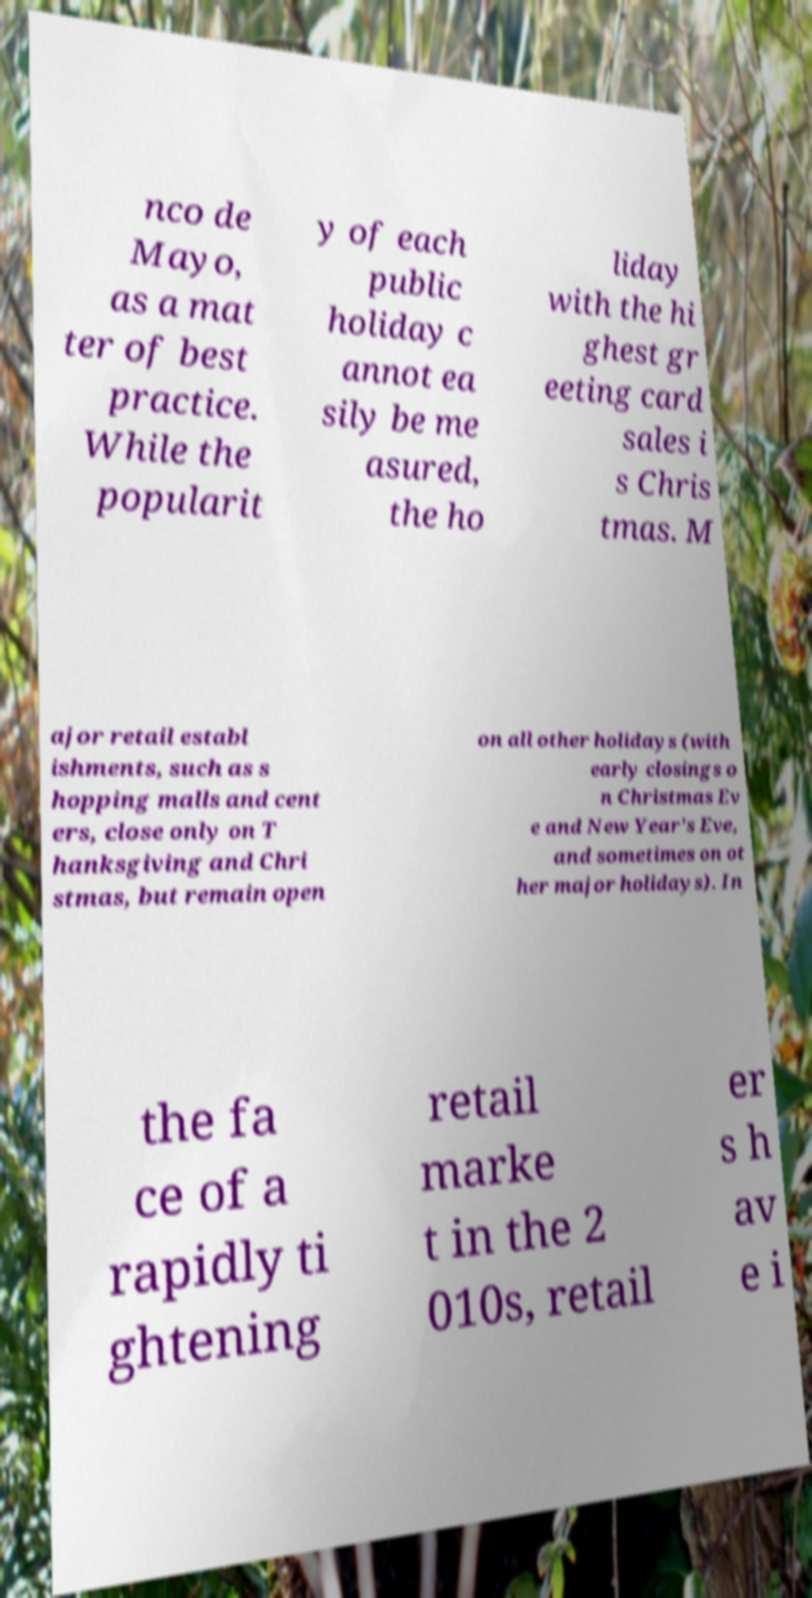What messages or text are displayed in this image? I need them in a readable, typed format. nco de Mayo, as a mat ter of best practice. While the popularit y of each public holiday c annot ea sily be me asured, the ho liday with the hi ghest gr eeting card sales i s Chris tmas. M ajor retail establ ishments, such as s hopping malls and cent ers, close only on T hanksgiving and Chri stmas, but remain open on all other holidays (with early closings o n Christmas Ev e and New Year's Eve, and sometimes on ot her major holidays). In the fa ce of a rapidly ti ghtening retail marke t in the 2 010s, retail er s h av e i 